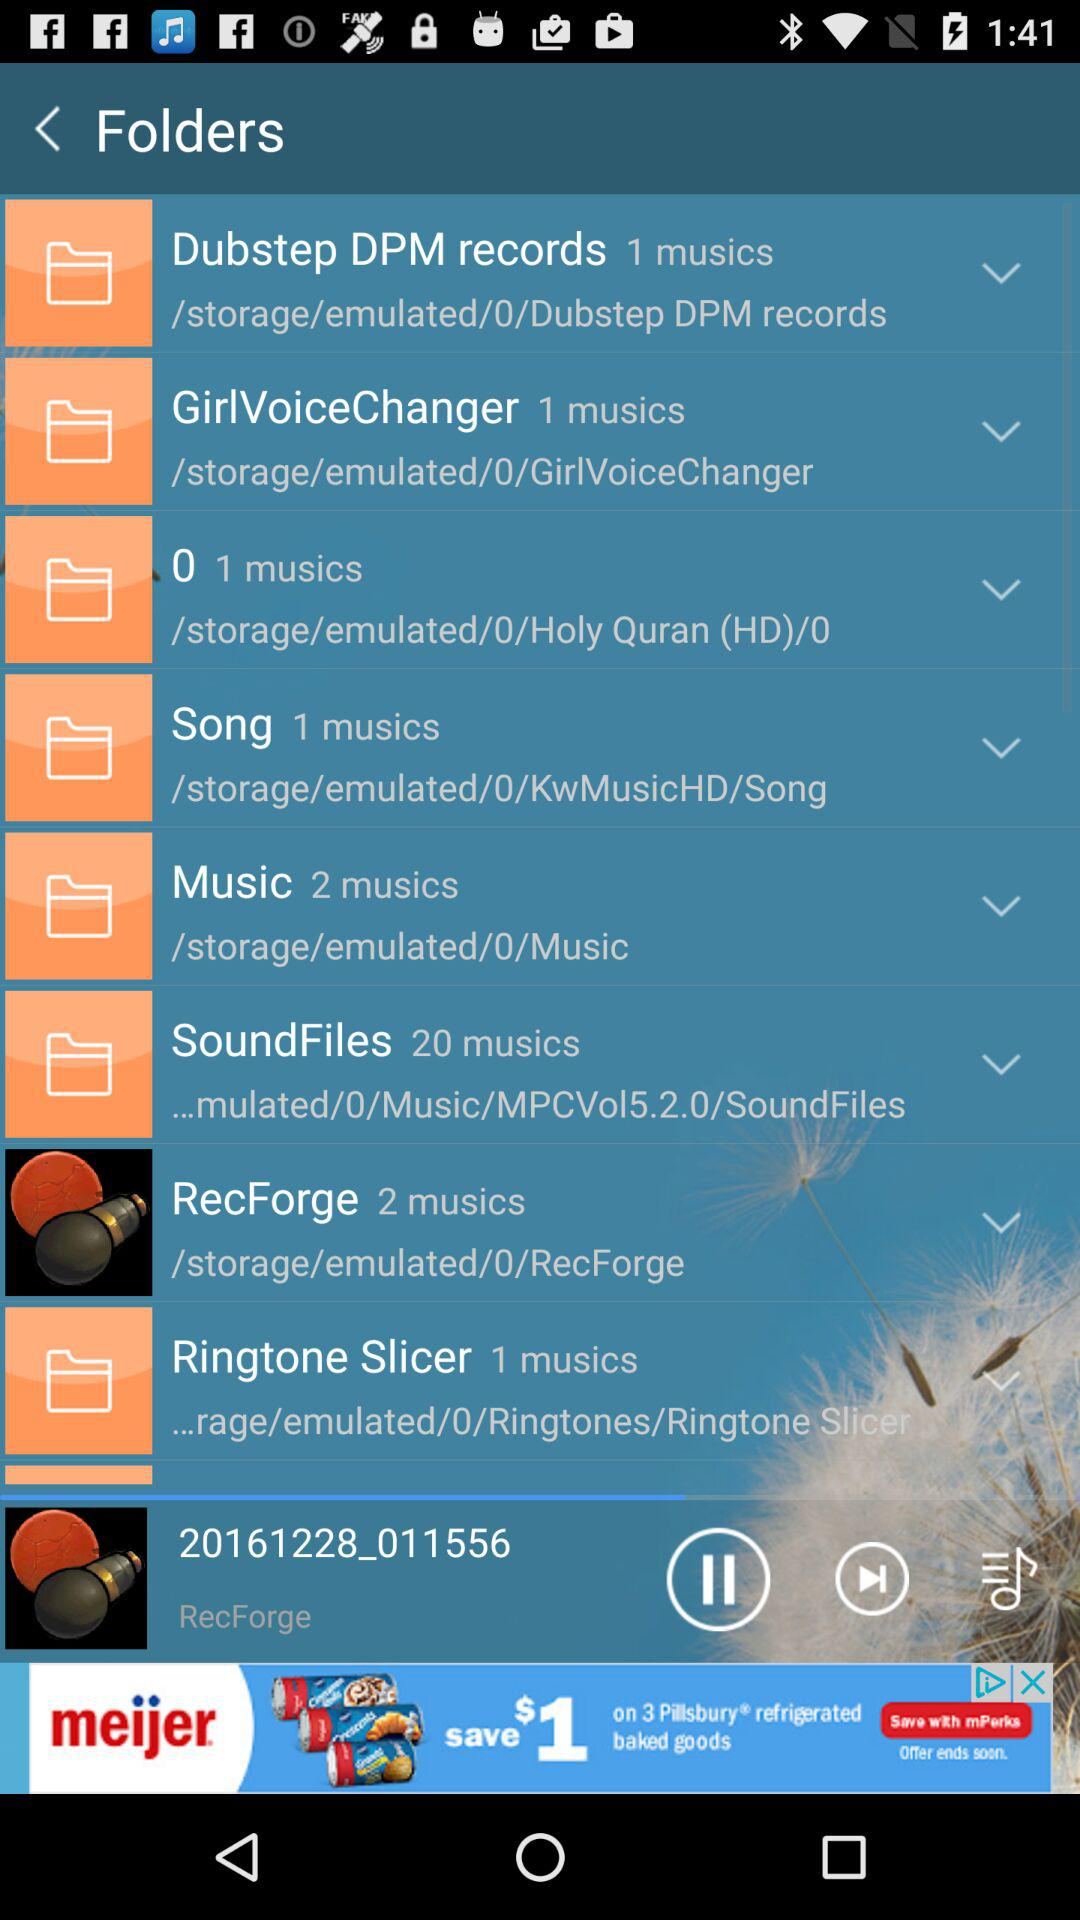Which track is currently playing? The currently playing track is "20161228_011556". 